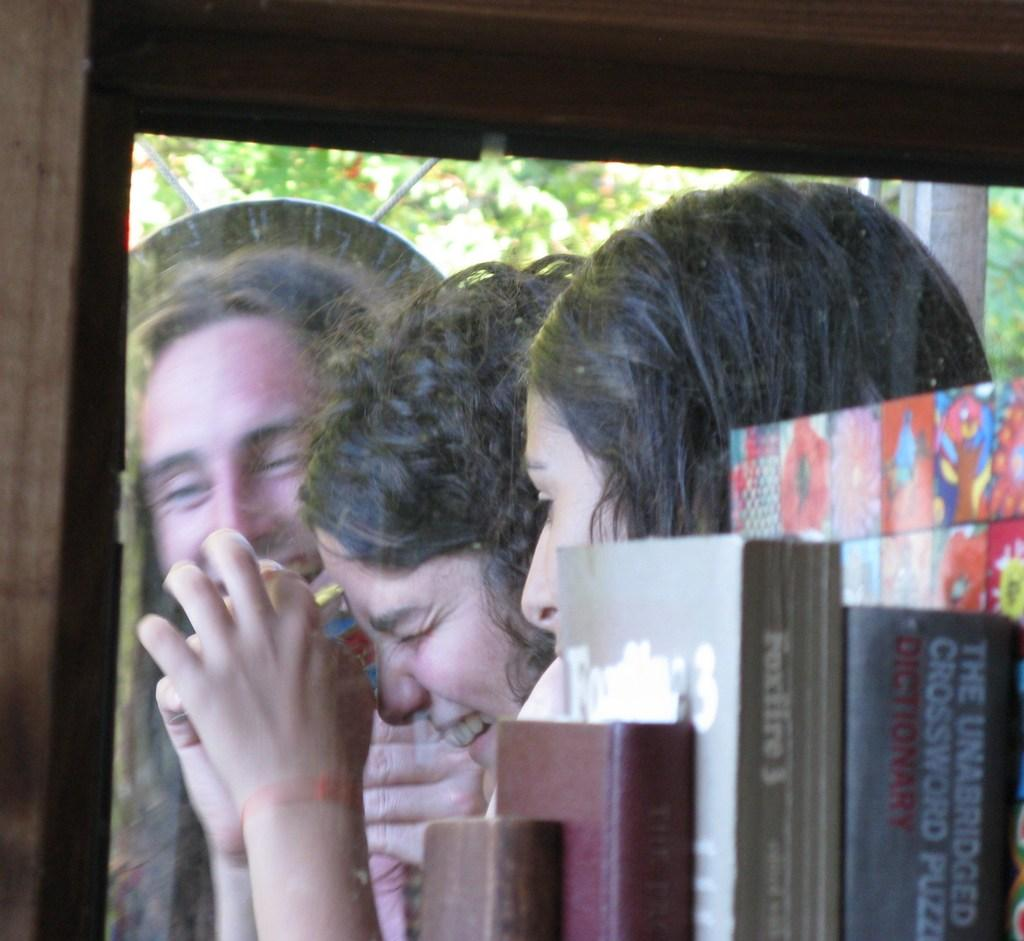How many people are in the image? There are three persons in the image. What expressions do the people have? Both of the persons are smiling. What objects can be seen in the image besides the people? There are books visible in the image. What is on top of the two books? There is something on top of the two books, but the specific object is not mentioned in the facts. What color is the brown thing in the image? There is a brown color thing in the image, but the specific object is not mentioned in the facts. Can you see any children playing in the quicksand in the image? There is no mention of children or quicksand in the image, so this scenario is not present. Is there a goat visible in the image? There is no mention of a goat in the image, so it is not visible. 